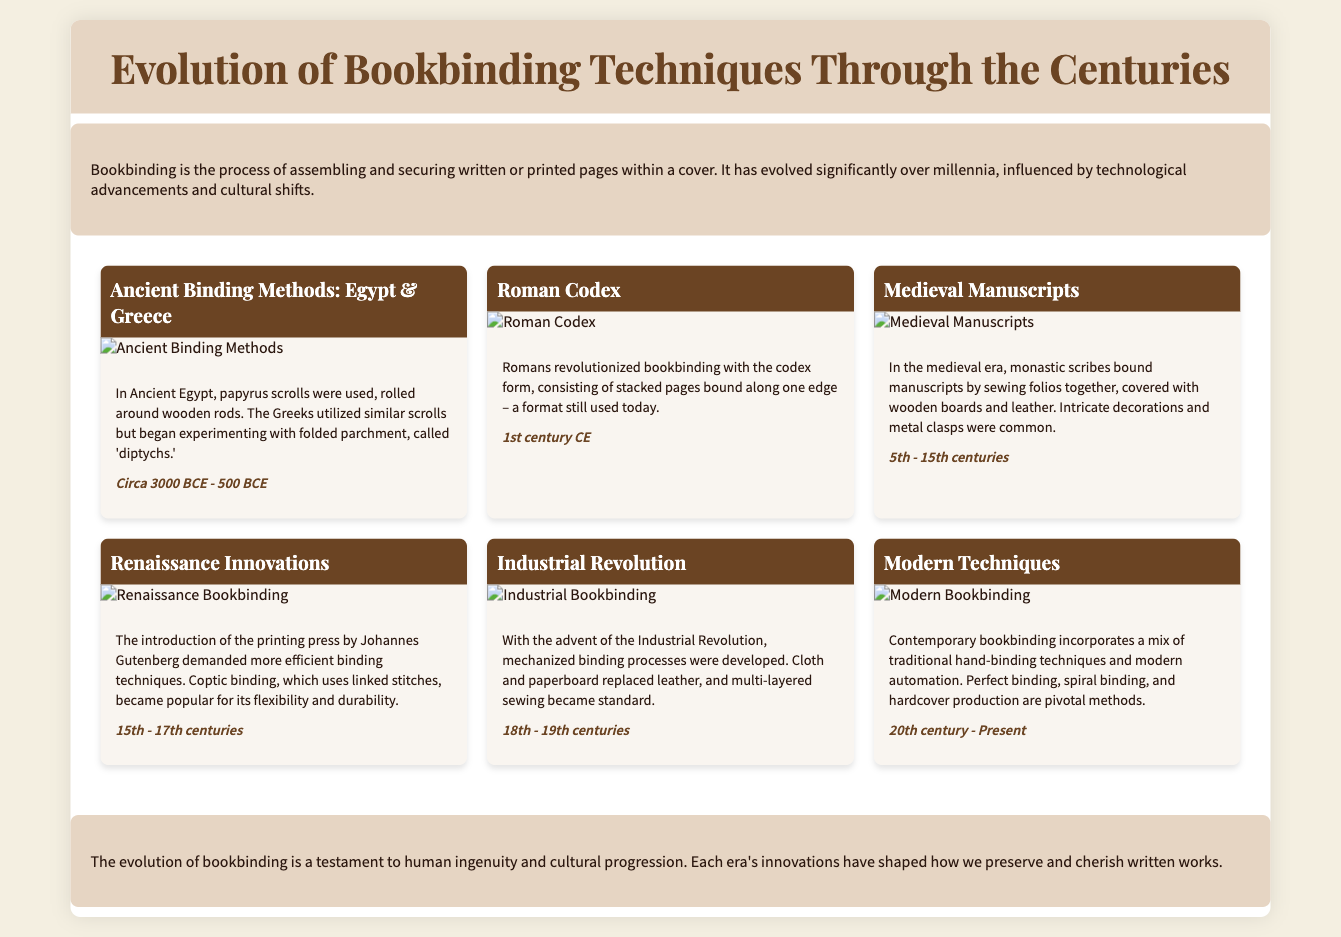what binding method was used in Ancient Egypt? The document states that Ancient Egyptians used papyrus scrolls rolled around wooden rods as their binding method.
Answer: papyrus scrolls what major innovation did Romans introduce in bookbinding? The document highlights that Romans revolutionized bookbinding by introducing the codex form, consisting of stacked pages bound along one edge.
Answer: codex during which period was Coptic binding popular? According to the timeline, Coptic binding became popular during the Renaissance, as noted in the section discussing Renaissance Innovations.
Answer: 15th - 17th centuries what were the common materials used in medieval binding? The document mentions that medieval manuscripts were typically covered with wooden boards and leather, indicating the materials used.
Answer: wooden boards and leather which century marks the beginning of modern bookbinding techniques? The timeline indicating the era of modern bookbinding starts from the 20th century, according to the document.
Answer: 20th century what factor significantly influenced the evolution of bookbinding during the Renaissance? The introduction of the printing press by Johannes Gutenberg is noted as a significant factor that demanded more efficient binding techniques during the Renaissance.
Answer: printing press how did the Industrial Revolution affect bookbinding? The document explains that the Industrial Revolution led to the development of mechanized binding processes, indicating a major shift in techniques.
Answer: mechanized binding processes which era is characterized by the use of intricate decorations and metal clasps? According to the timeline, the medieval era is noted for the use of intricate decorations and metal clasps in bookbinding.
Answer: medieval era what aspect of bookbinding techniques does the conclusion emphasize? The conclusion emphasizes that the evolution of bookbinding reflects human ingenuity and cultural progression throughout history.
Answer: human ingenuity and cultural progression 